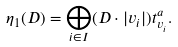<formula> <loc_0><loc_0><loc_500><loc_500>\eta _ { 1 } ( D ) = \bigoplus _ { i \in I } ( D \cdot | v _ { i } | ) t ^ { a } _ { v _ { i } } .</formula> 